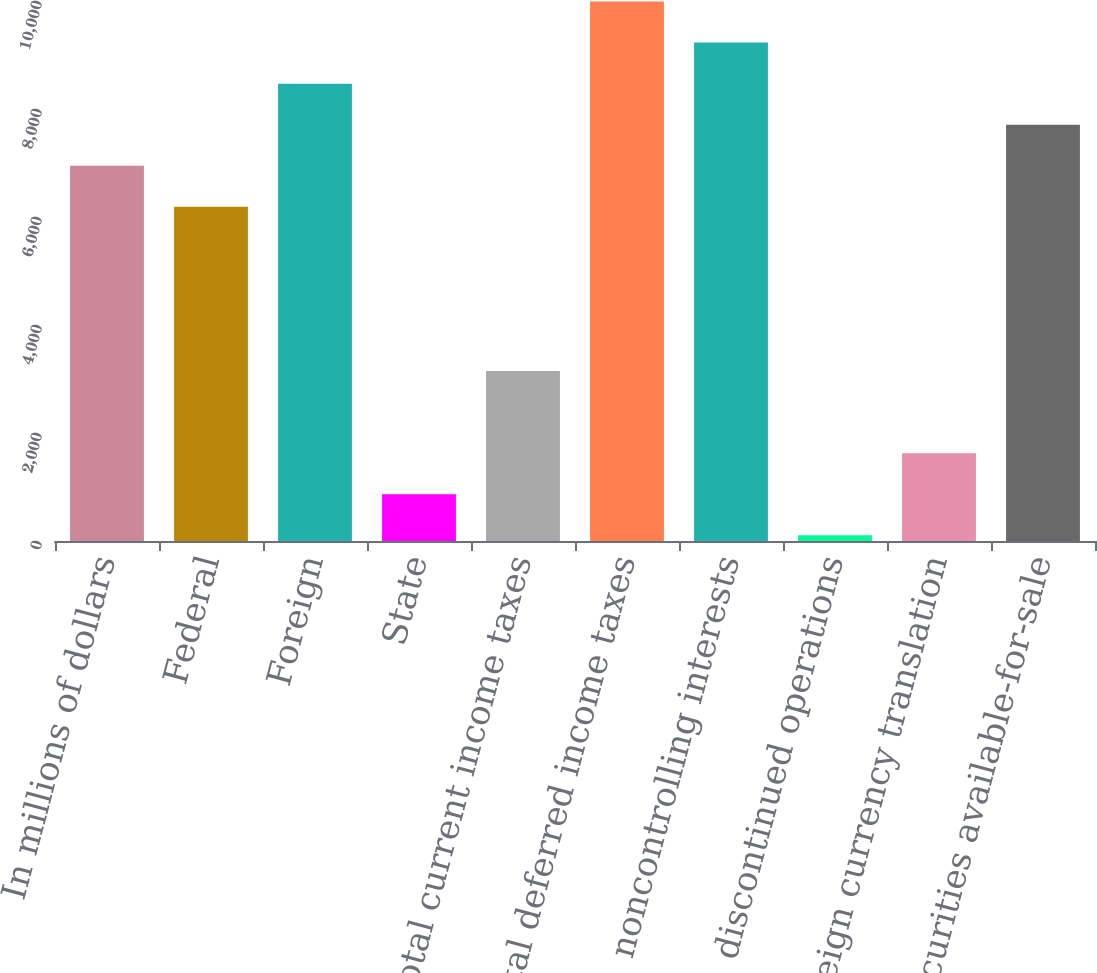Convert chart to OTSL. <chart><loc_0><loc_0><loc_500><loc_500><bar_chart><fcel>In millions of dollars<fcel>Federal<fcel>Foreign<fcel>State<fcel>Total current income taxes<fcel>Total deferred income taxes<fcel>noncontrolling interests<fcel>discontinued operations<fcel>Foreign currency translation<fcel>Securities available-for-sale<nl><fcel>6948.7<fcel>6188.4<fcel>8469.3<fcel>866.3<fcel>3147.2<fcel>9989.9<fcel>9229.6<fcel>106<fcel>1626.6<fcel>7709<nl></chart> 